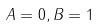Convert formula to latex. <formula><loc_0><loc_0><loc_500><loc_500>A = 0 , B = 1</formula> 